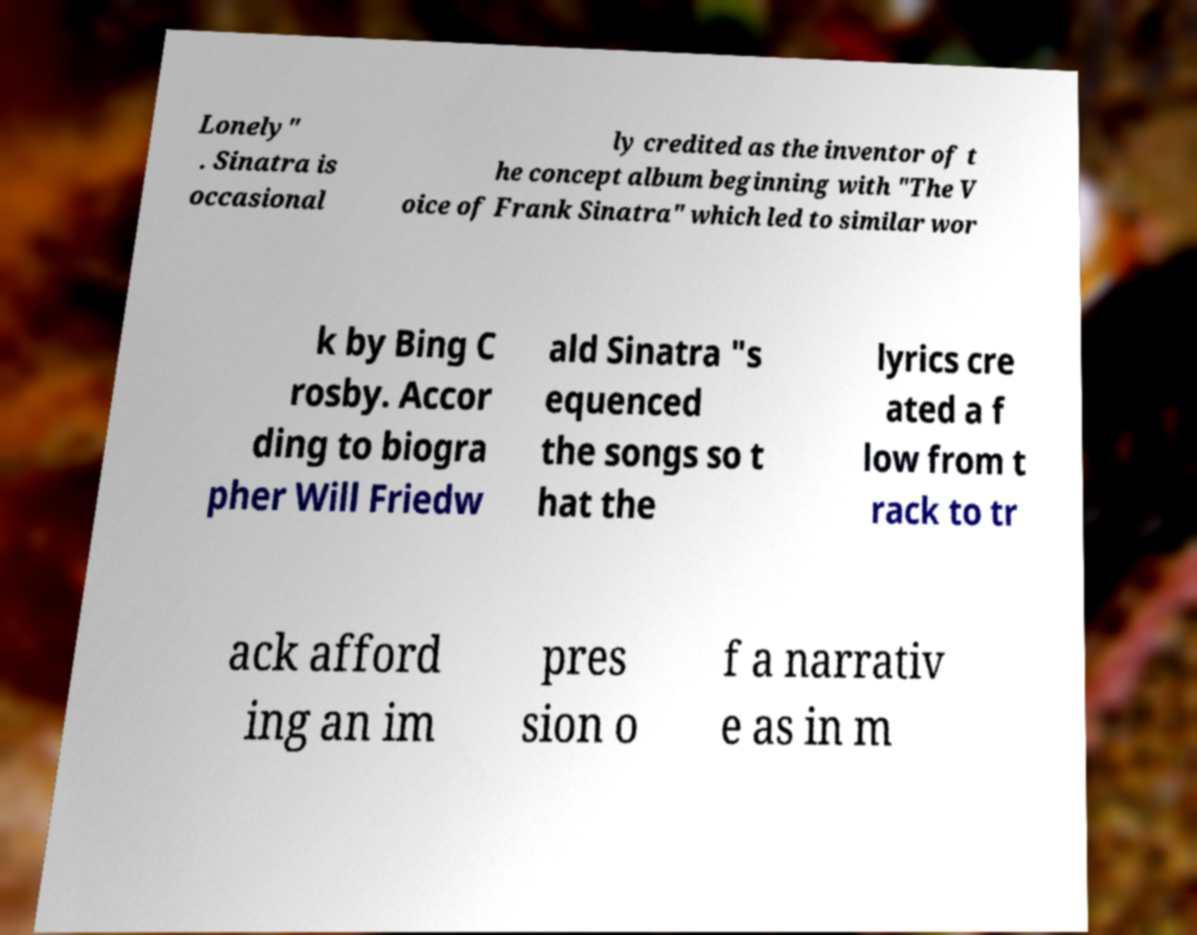Please identify and transcribe the text found in this image. Lonely" . Sinatra is occasional ly credited as the inventor of t he concept album beginning with "The V oice of Frank Sinatra" which led to similar wor k by Bing C rosby. Accor ding to biogra pher Will Friedw ald Sinatra "s equenced the songs so t hat the lyrics cre ated a f low from t rack to tr ack afford ing an im pres sion o f a narrativ e as in m 